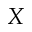<formula> <loc_0><loc_0><loc_500><loc_500>X</formula> 